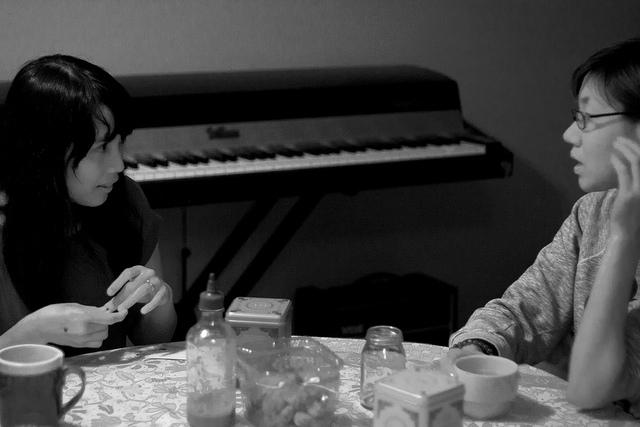What type musician lives here? pianist 